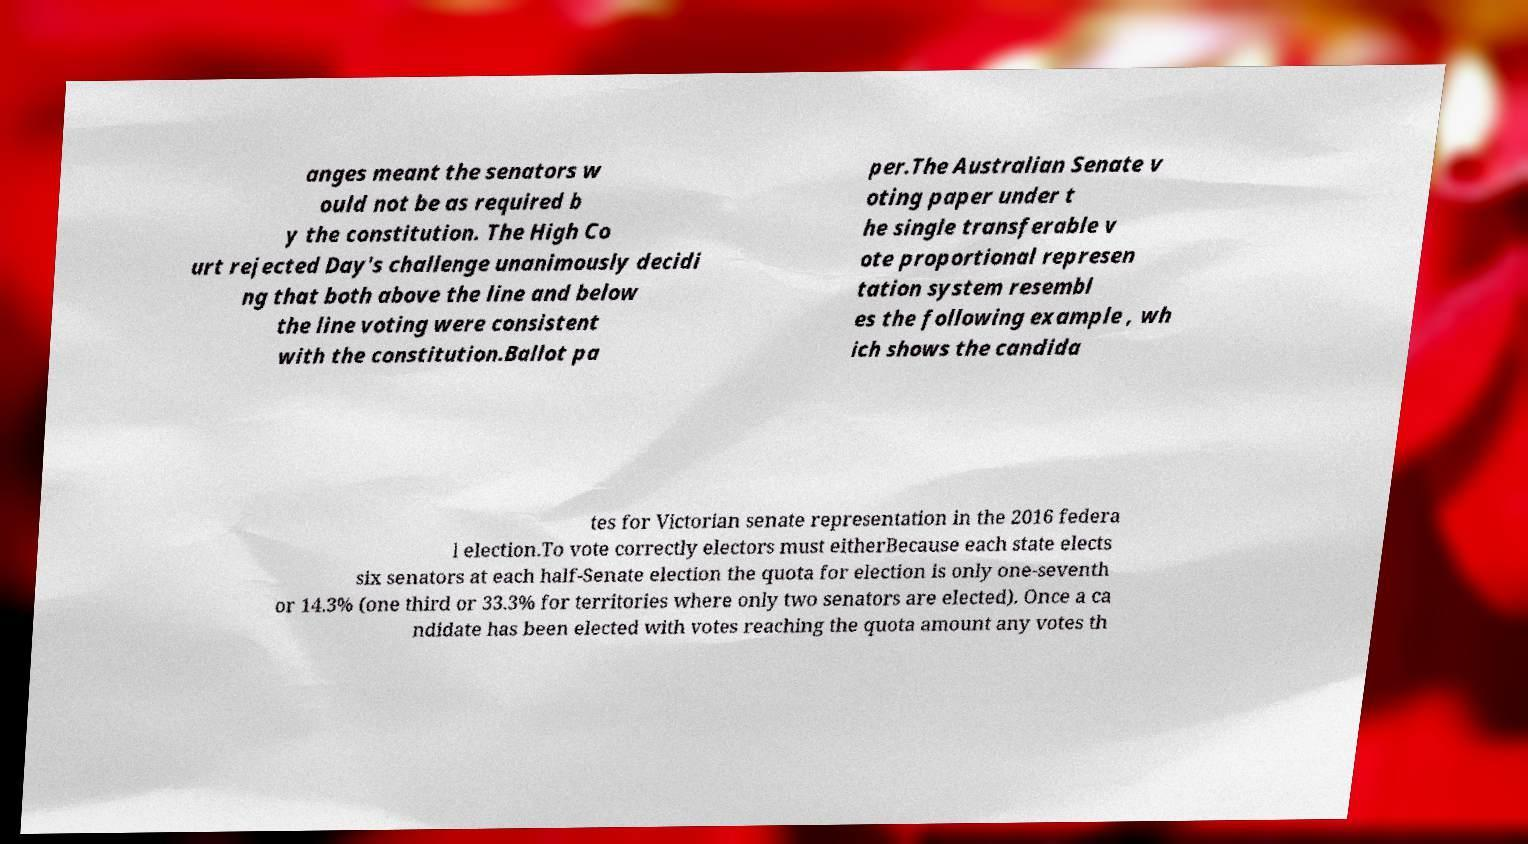Can you accurately transcribe the text from the provided image for me? anges meant the senators w ould not be as required b y the constitution. The High Co urt rejected Day's challenge unanimously decidi ng that both above the line and below the line voting were consistent with the constitution.Ballot pa per.The Australian Senate v oting paper under t he single transferable v ote proportional represen tation system resembl es the following example , wh ich shows the candida tes for Victorian senate representation in the 2016 federa l election.To vote correctly electors must eitherBecause each state elects six senators at each half-Senate election the quota for election is only one-seventh or 14.3% (one third or 33.3% for territories where only two senators are elected). Once a ca ndidate has been elected with votes reaching the quota amount any votes th 